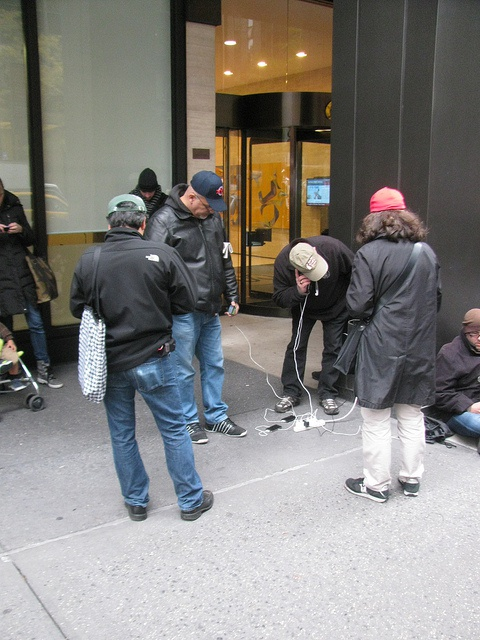Describe the objects in this image and their specific colors. I can see people in black, gray, and blue tones, people in black, gray, lightgray, and darkgray tones, people in black, gray, and blue tones, people in black, gray, lightgray, and darkgray tones, and people in black, gray, navy, and darkblue tones in this image. 